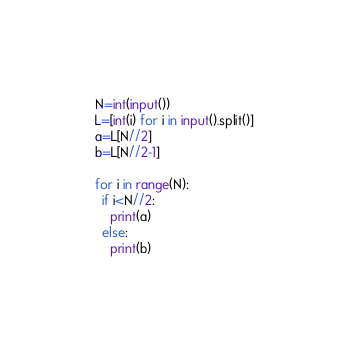Convert code to text. <code><loc_0><loc_0><loc_500><loc_500><_Python_>N=int(input())
L=[int(i) for i in input().split()]
a=L[N//2]
b=L[N//2-1]
 
for i in range(N):
  if i<N//2:
    print(a)
  else:
    print(b)</code> 